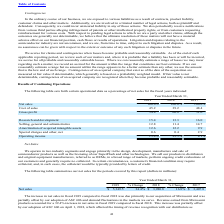From Microchip Technology's financial document, Which years does the table provide information for certain operational data as a percentage of net sales? The document contains multiple relevant values: 2019, 2018, 2017. From the document: "2019 2018 2017 2019 2018 2017 2019 2018 2017..." Also, What was the percentage of cost of sales of net sales in 2019? According to the financial document, 45.2 (percentage). The relevant text states: "Cost of sales 45.2 39.2 48.4..." Also, What was the percentage of gross profit of net sales in 2018? According to the financial document, 60.8 (percentage). The relevant text states: "Gross profit 54.8 60.8 51.6..." Also, can you calculate: What was the percentage change in gross profit of net sales between 2017 and 2018? Based on the calculation: 60.8-51.6, the result is 9.2 (percentage). This is based on the information: "Gross profit 54.8 60.8 51.6 Gross profit 54.8 60.8 51.6..." The key data points involved are: 51.6, 60.8. Also, How many years did cost of sales of net sales exceed 40%? Counting the relevant items in the document: 2019, 2017, I find 2 instances. The key data points involved are: 2017, 2019. Also, can you calculate: What was the percentage change in operating income of net sales between 2018 and 2019? Based on the calculation: 13.4-23.5, the result is -10.1 (percentage). This is based on the information: "Operating income 13.4% 23.5% 8.1% Operating income 13.4% 23.5% 8.1%..." The key data points involved are: 13.4, 23.5. 